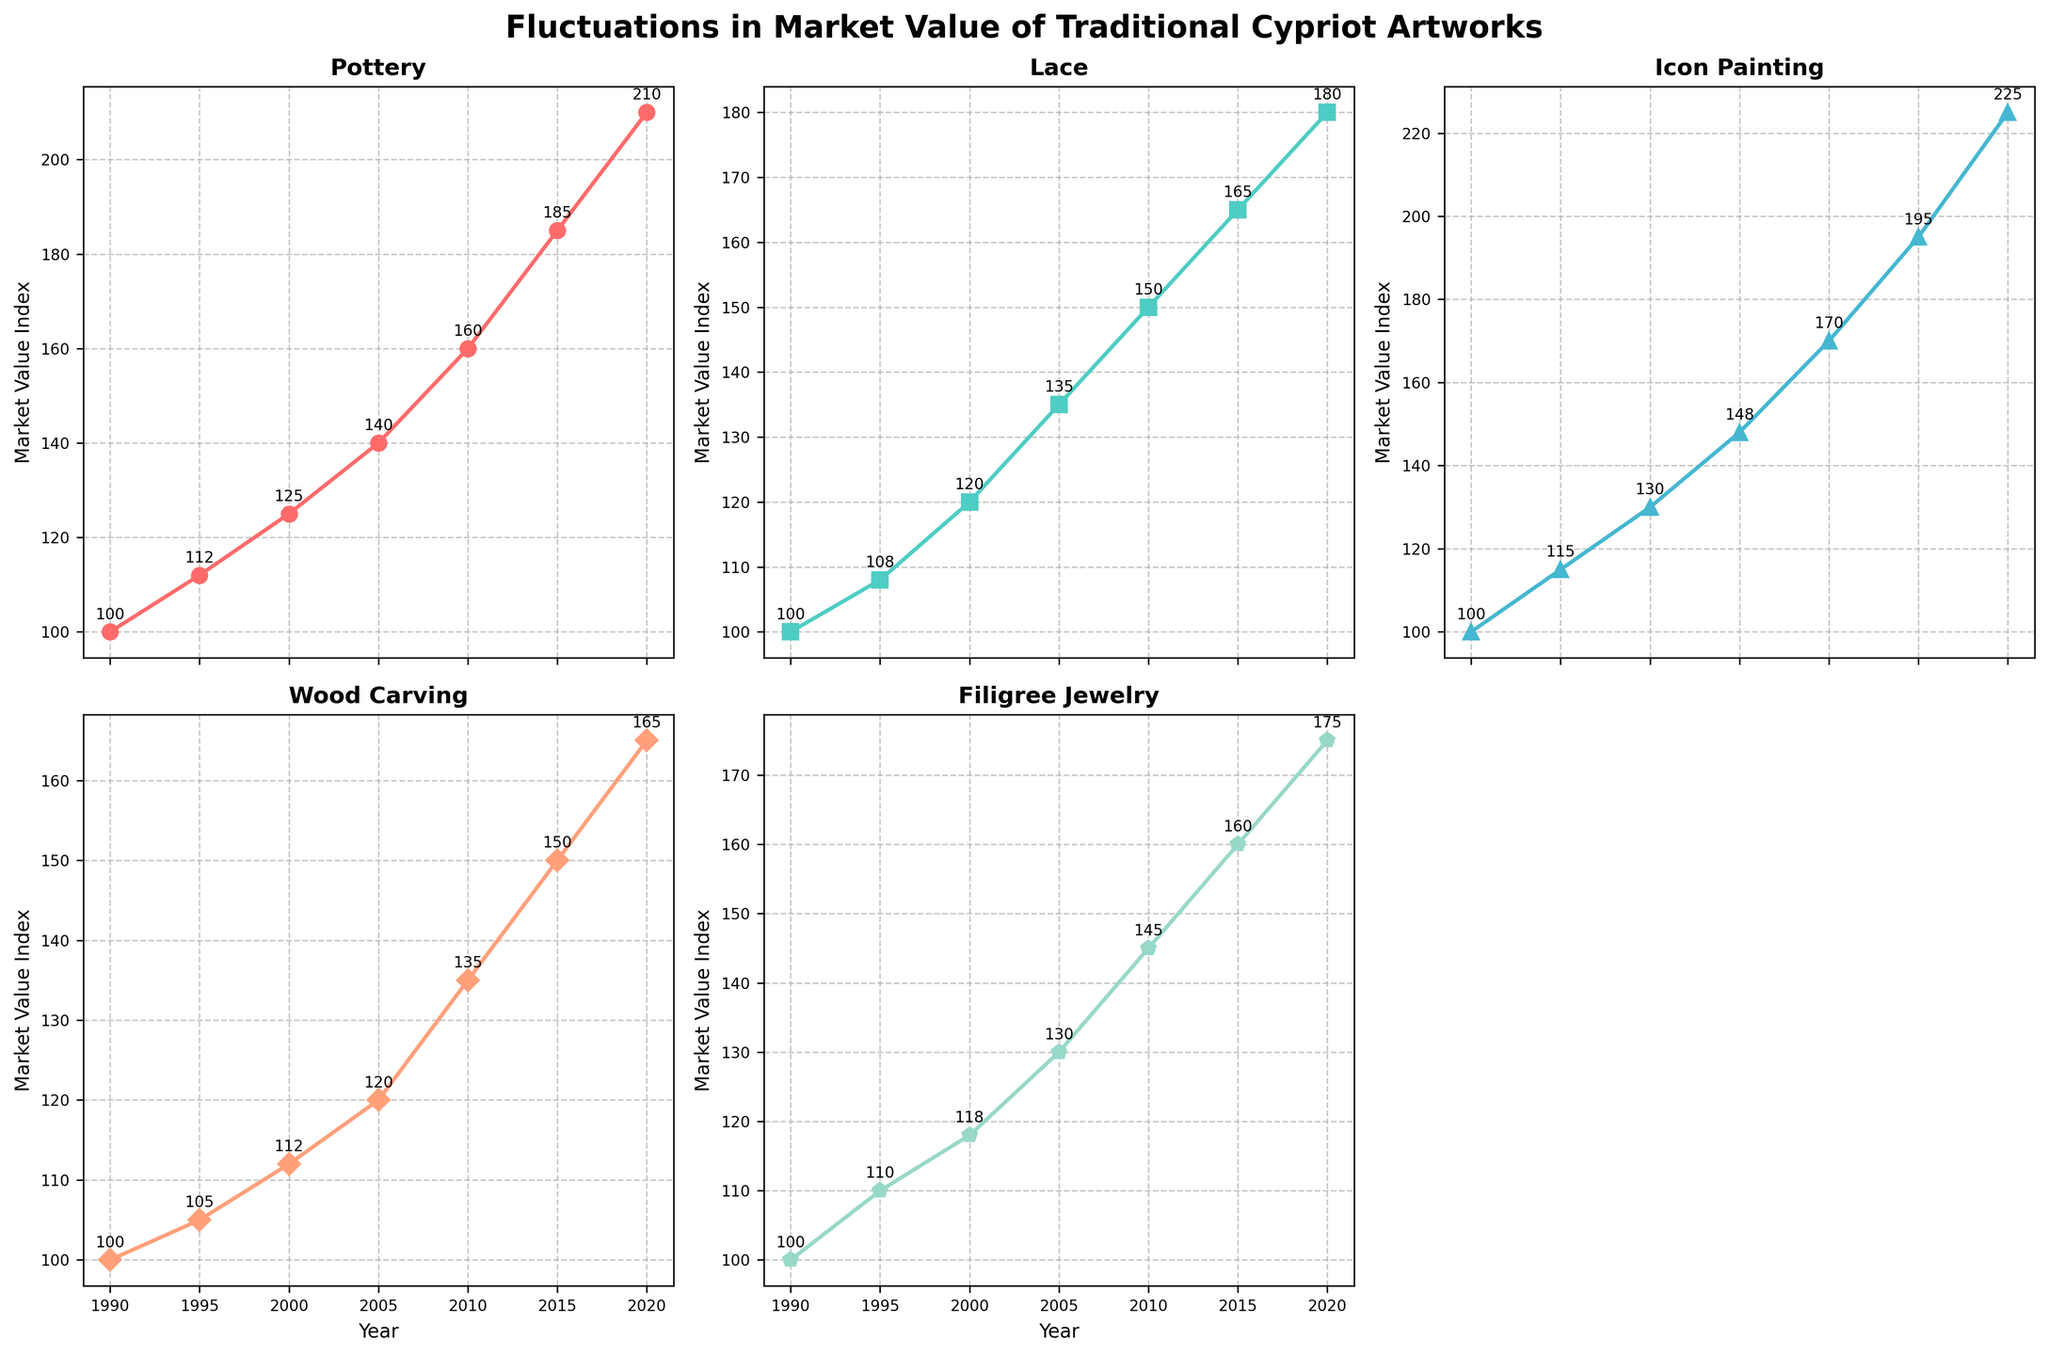How many types of traditional Cypriot artworks are shown in the figure? There are different subplots for each art form, each labeled with its title. Count the number of unique subplots to find the number of artwork types.
Answer: 5 What is the overall title of the figure? The overall title is prominently displayed at the top of the figure.
Answer: Fluctuations in Market Value of Traditional Cypriot Artworks Which year had the highest market value index for Pottery? Look at the Pottery subplot and identify the year with the highest point on the line.
Answer: 2020 Between 2005 and 2010, which art form saw the most significant increase in market value? Examine the subplots for each art form and compare the differences in market values between 2005 and 2010.
Answer: Icon Painting What was the market value index for Wood Carving in 2015? In the Wood Carving subplot, locate the data point for the year 2015 and read the corresponding value.
Answer: 150 How much did the market value index for Filigree Jewelry change from 1995 to 2020? Subtract the market value index for 1995 from the index for 2020 for Filigree Jewelry.
Answer: 65 Which art form experienced the least overall increase in market value index from 1990 to 2020? Compare the differences in market values between 1990 and 2020 for each art form and identify the smallest difference.
Answer: Wood Carving Between 1990 and 2000, which art form had the most stable market value index? Assess the line segments for each art form and identify which one has the least variation over the specified years.
Answer: Lace What is the trend in market value index for Lace from 1995 to 2020? Observe the Lace subplot and describe the overall direction of the line from 1995 to 2020.
Answer: Increasing How do the market value indices for Icon Painting and Filigree Jewelry in 2005 compare? Compare the data points for Icon Painting and Filigree Jewelry in the year 2005 and determine their relative values.
Answer: Icon Painting is higher 